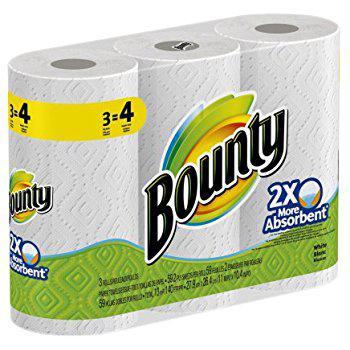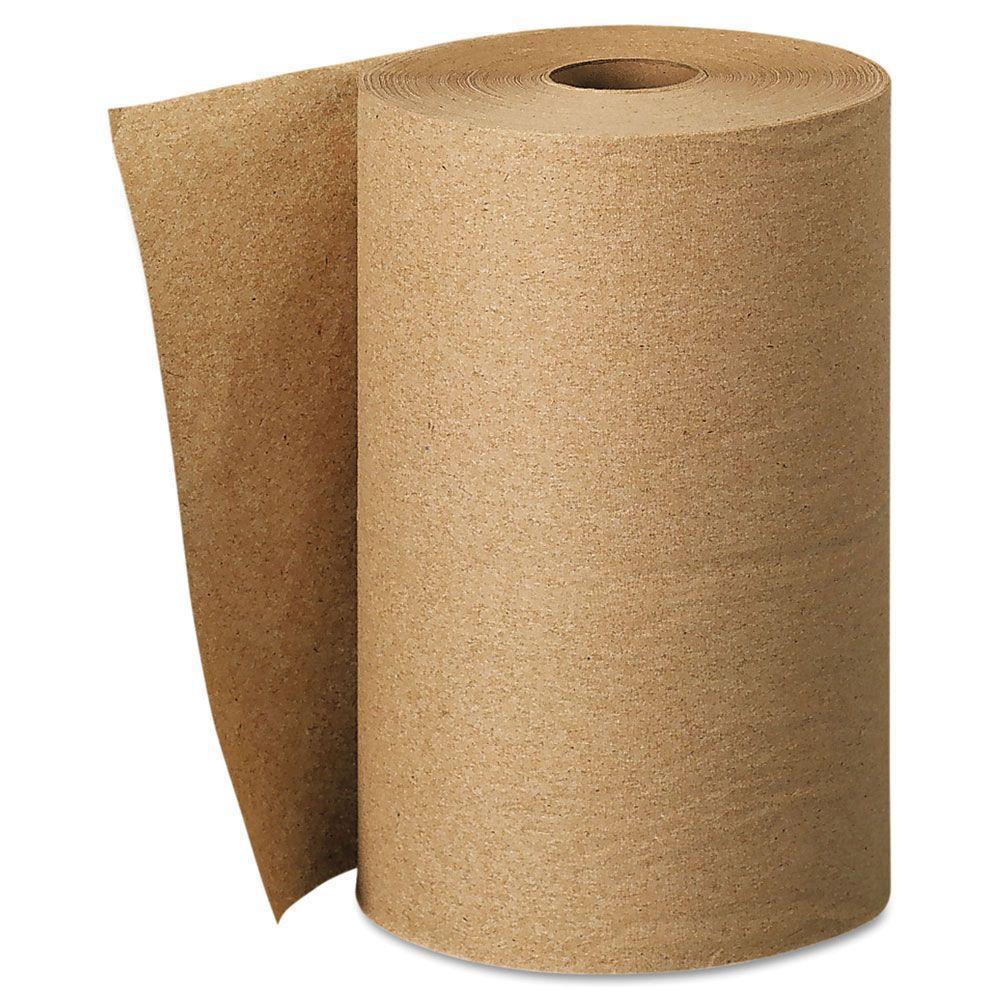The first image is the image on the left, the second image is the image on the right. Evaluate the accuracy of this statement regarding the images: "One roll of paper towels is brown and at least three are white.". Is it true? Answer yes or no. Yes. The first image is the image on the left, the second image is the image on the right. Examine the images to the left and right. Is the description "There are no less than three rolls of paper towels in the image on the left." accurate? Answer yes or no. Yes. 